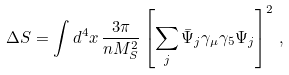<formula> <loc_0><loc_0><loc_500><loc_500>\Delta S = \int d ^ { 4 } x \, \frac { 3 \pi } { n M _ { S } ^ { 2 } } \left [ \sum _ { j } \bar { \Psi } _ { j } \gamma _ { \mu } \gamma _ { 5 } \Psi _ { j } \right ] ^ { 2 } \, ,</formula> 